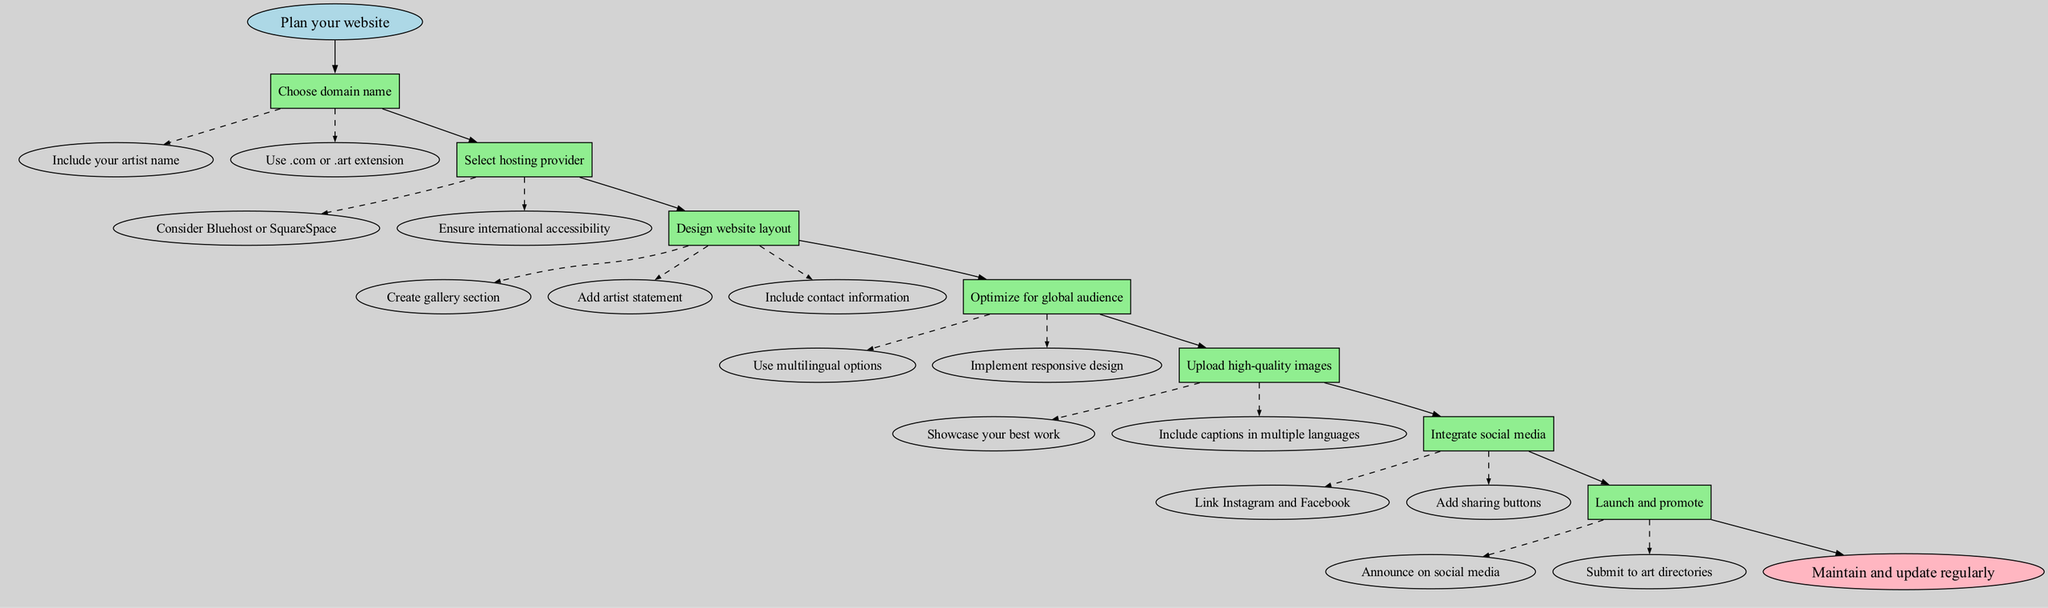What is the first step in creating an artist website? The diagram indicates that the first step is "Plan your website," which is the starting node.
Answer: Plan your website How many main steps are listed in the diagram? There are seven main steps provided in the diagram, from "Choose domain name" to "Launch and promote."
Answer: 7 Which step comes directly after "Select hosting provider"? Following the "Select hosting provider" step, the next node in the flow is "Design website layout."
Answer: Design website layout What are the two substeps under "Upload high-quality images"? The substeps listed under "Upload high-quality images" are "Showcase your best work" and "Include captions in multiple languages."
Answer: Showcase your best work, Include captions in multiple languages What is the end node of the diagram? The diagram concludes with the end node labeled "Maintain and update regularly."
Answer: Maintain and update regularly Which steps focus on making the website accessible to a global audience? The "Optimize for global audience" step directly addresses this focus, which includes the substeps "Use multilingual options" and "Implement responsive design."
Answer: Optimize for global audience How are the relationships between nodes represented in the diagram? The relationships between nodes are represented by directed edges, indicating the flow from one step to the next, with some connections shown as dashed for substeps.
Answer: Directed edges What should you do first in the "Design website layout" step? In the "Design website layout" step, the first substep is to "Create gallery section."
Answer: Create gallery section 